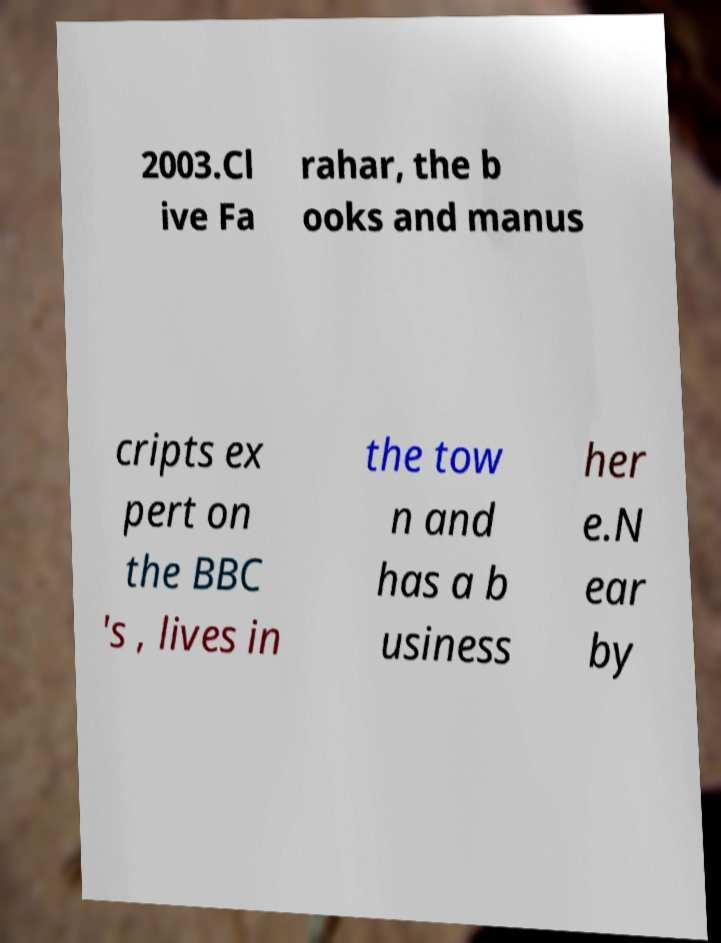Please read and relay the text visible in this image. What does it say? 2003.Cl ive Fa rahar, the b ooks and manus cripts ex pert on the BBC 's , lives in the tow n and has a b usiness her e.N ear by 